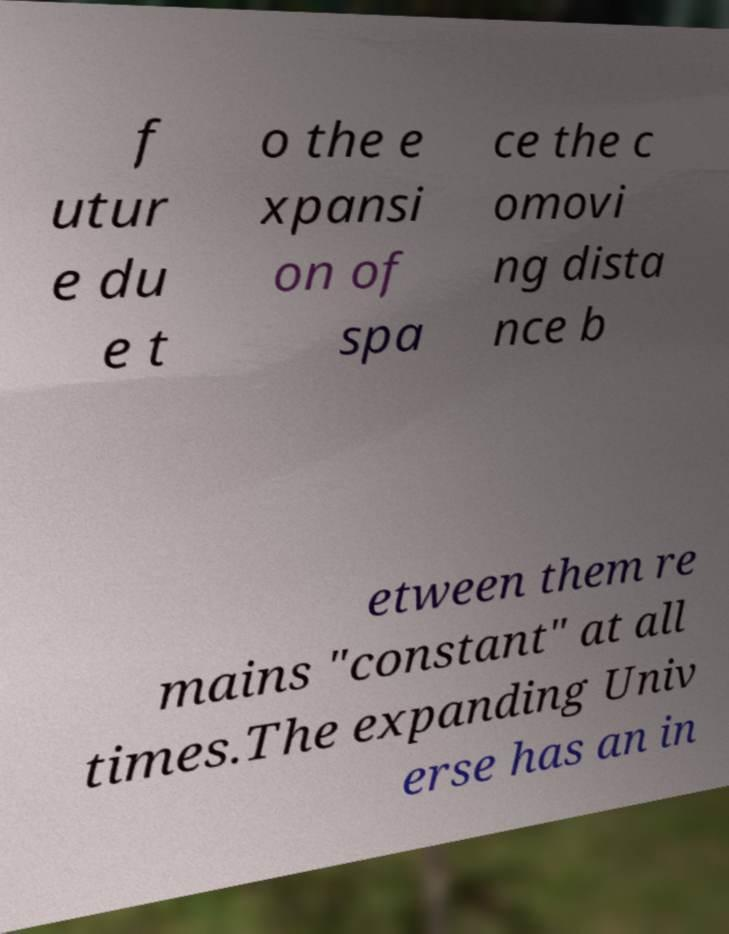Can you accurately transcribe the text from the provided image for me? f utur e du e t o the e xpansi on of spa ce the c omovi ng dista nce b etween them re mains "constant" at all times.The expanding Univ erse has an in 